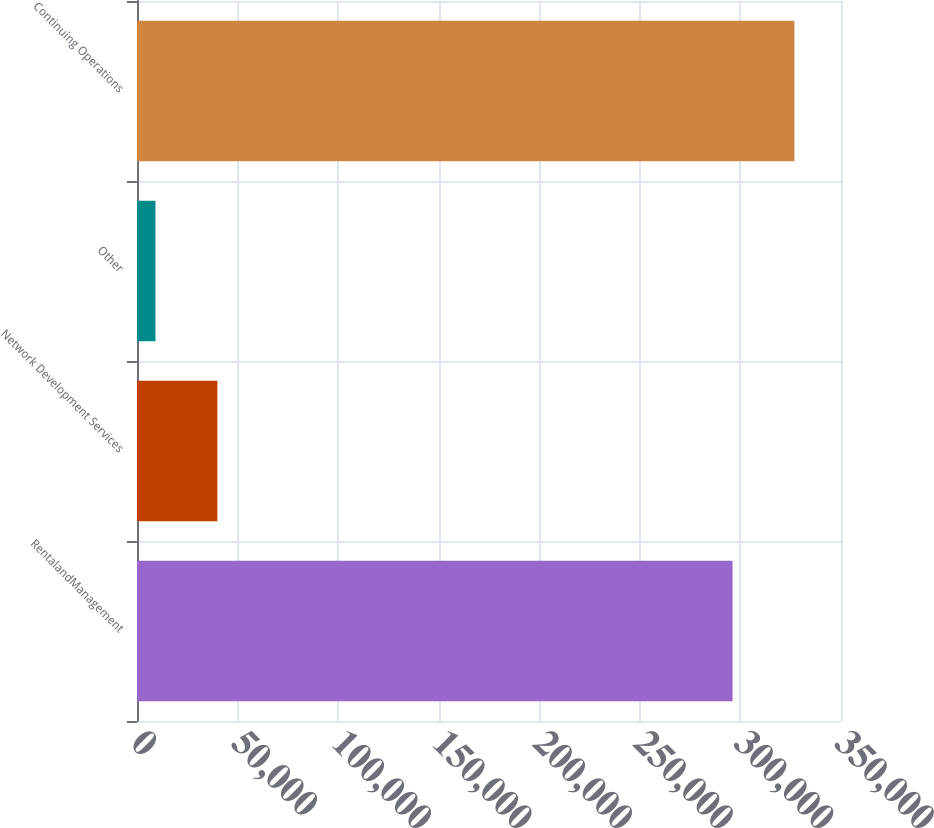Convert chart to OTSL. <chart><loc_0><loc_0><loc_500><loc_500><bar_chart><fcel>RentalandManagement<fcel>Network Development Services<fcel>Other<fcel>Continuing Operations<nl><fcel>296089<fcel>39958.6<fcel>9190<fcel>326858<nl></chart> 